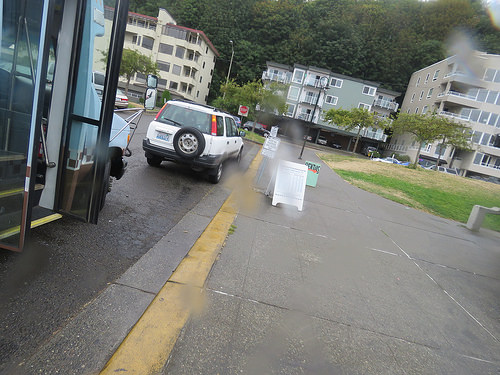<image>
Is there a bus to the left of the car? No. The bus is not to the left of the car. From this viewpoint, they have a different horizontal relationship. Is the building behind the building? Yes. From this viewpoint, the building is positioned behind the building, with the building partially or fully occluding the building. Where is the car in relation to the building? Is it in front of the building? Yes. The car is positioned in front of the building, appearing closer to the camera viewpoint. 